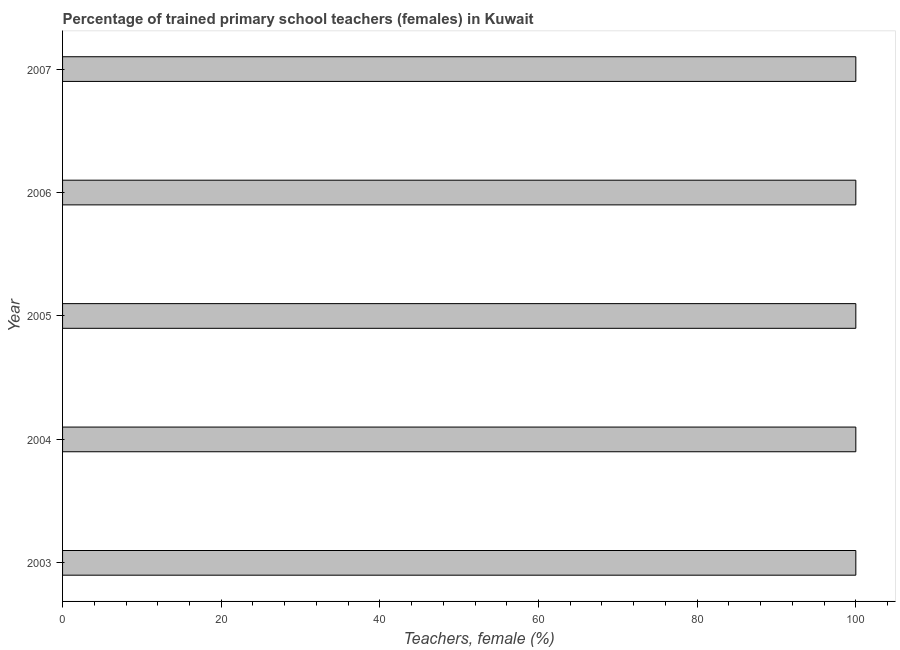Does the graph contain grids?
Your answer should be compact. No. What is the title of the graph?
Keep it short and to the point. Percentage of trained primary school teachers (females) in Kuwait. What is the label or title of the X-axis?
Ensure brevity in your answer.  Teachers, female (%). What is the label or title of the Y-axis?
Provide a short and direct response. Year. Across all years, what is the minimum percentage of trained female teachers?
Provide a short and direct response. 100. In which year was the percentage of trained female teachers maximum?
Offer a terse response. 2003. What is the average percentage of trained female teachers per year?
Make the answer very short. 100. What is the median percentage of trained female teachers?
Ensure brevity in your answer.  100. In how many years, is the percentage of trained female teachers greater than 56 %?
Your response must be concise. 5. Do a majority of the years between 2007 and 2004 (inclusive) have percentage of trained female teachers greater than 100 %?
Your response must be concise. Yes. Is the percentage of trained female teachers in 2003 less than that in 2007?
Offer a very short reply. No. What is the difference between the highest and the second highest percentage of trained female teachers?
Your response must be concise. 0. In how many years, is the percentage of trained female teachers greater than the average percentage of trained female teachers taken over all years?
Keep it short and to the point. 0. How many bars are there?
Your answer should be very brief. 5. What is the Teachers, female (%) in 2003?
Offer a terse response. 100. What is the Teachers, female (%) in 2004?
Provide a short and direct response. 100. What is the Teachers, female (%) in 2007?
Your response must be concise. 100. What is the difference between the Teachers, female (%) in 2003 and 2006?
Your answer should be compact. 0. What is the difference between the Teachers, female (%) in 2003 and 2007?
Make the answer very short. 0. What is the difference between the Teachers, female (%) in 2004 and 2006?
Offer a terse response. 0. What is the difference between the Teachers, female (%) in 2004 and 2007?
Offer a very short reply. 0. What is the difference between the Teachers, female (%) in 2005 and 2006?
Provide a short and direct response. 0. What is the difference between the Teachers, female (%) in 2005 and 2007?
Provide a succinct answer. 0. What is the difference between the Teachers, female (%) in 2006 and 2007?
Offer a very short reply. 0. What is the ratio of the Teachers, female (%) in 2003 to that in 2004?
Give a very brief answer. 1. What is the ratio of the Teachers, female (%) in 2003 to that in 2006?
Your answer should be compact. 1. What is the ratio of the Teachers, female (%) in 2003 to that in 2007?
Your answer should be very brief. 1. What is the ratio of the Teachers, female (%) in 2004 to that in 2006?
Your answer should be compact. 1. What is the ratio of the Teachers, female (%) in 2005 to that in 2007?
Give a very brief answer. 1. What is the ratio of the Teachers, female (%) in 2006 to that in 2007?
Provide a succinct answer. 1. 